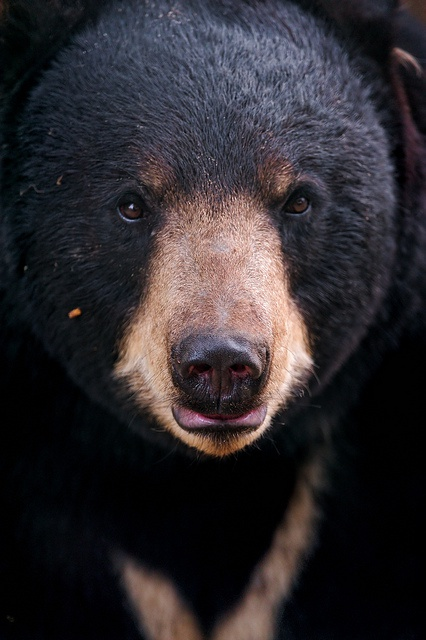Describe the objects in this image and their specific colors. I can see a bear in black, gray, and tan tones in this image. 